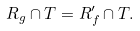Convert formula to latex. <formula><loc_0><loc_0><loc_500><loc_500>R _ { g } \cap T = R _ { f } ^ { \prime } \cap T .</formula> 